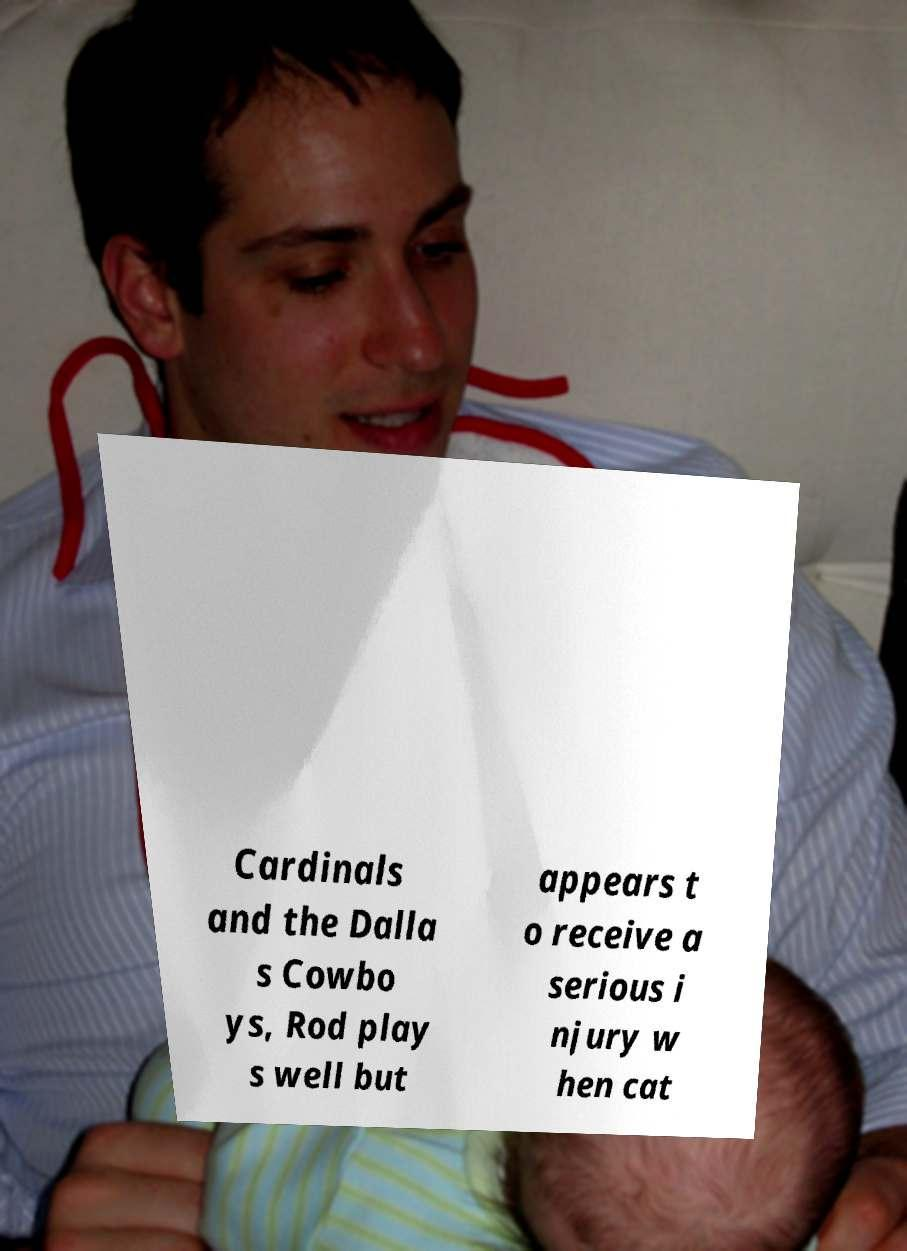Could you extract and type out the text from this image? Cardinals and the Dalla s Cowbo ys, Rod play s well but appears t o receive a serious i njury w hen cat 